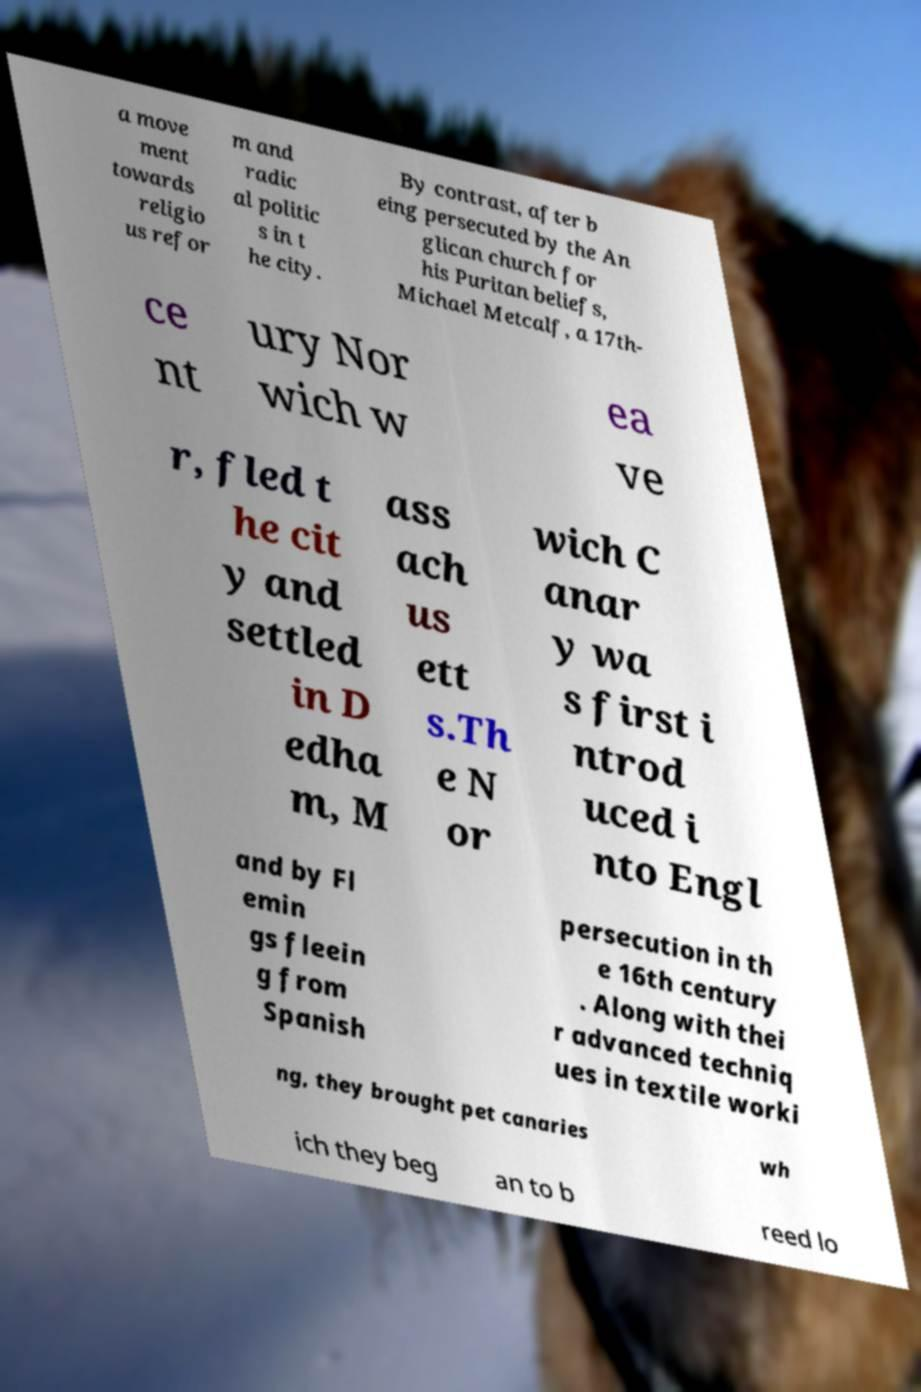Please identify and transcribe the text found in this image. a move ment towards religio us refor m and radic al politic s in t he city. By contrast, after b eing persecuted by the An glican church for his Puritan beliefs, Michael Metcalf, a 17th- ce nt ury Nor wich w ea ve r, fled t he cit y and settled in D edha m, M ass ach us ett s.Th e N or wich C anar y wa s first i ntrod uced i nto Engl and by Fl emin gs fleein g from Spanish persecution in th e 16th century . Along with thei r advanced techniq ues in textile worki ng, they brought pet canaries wh ich they beg an to b reed lo 